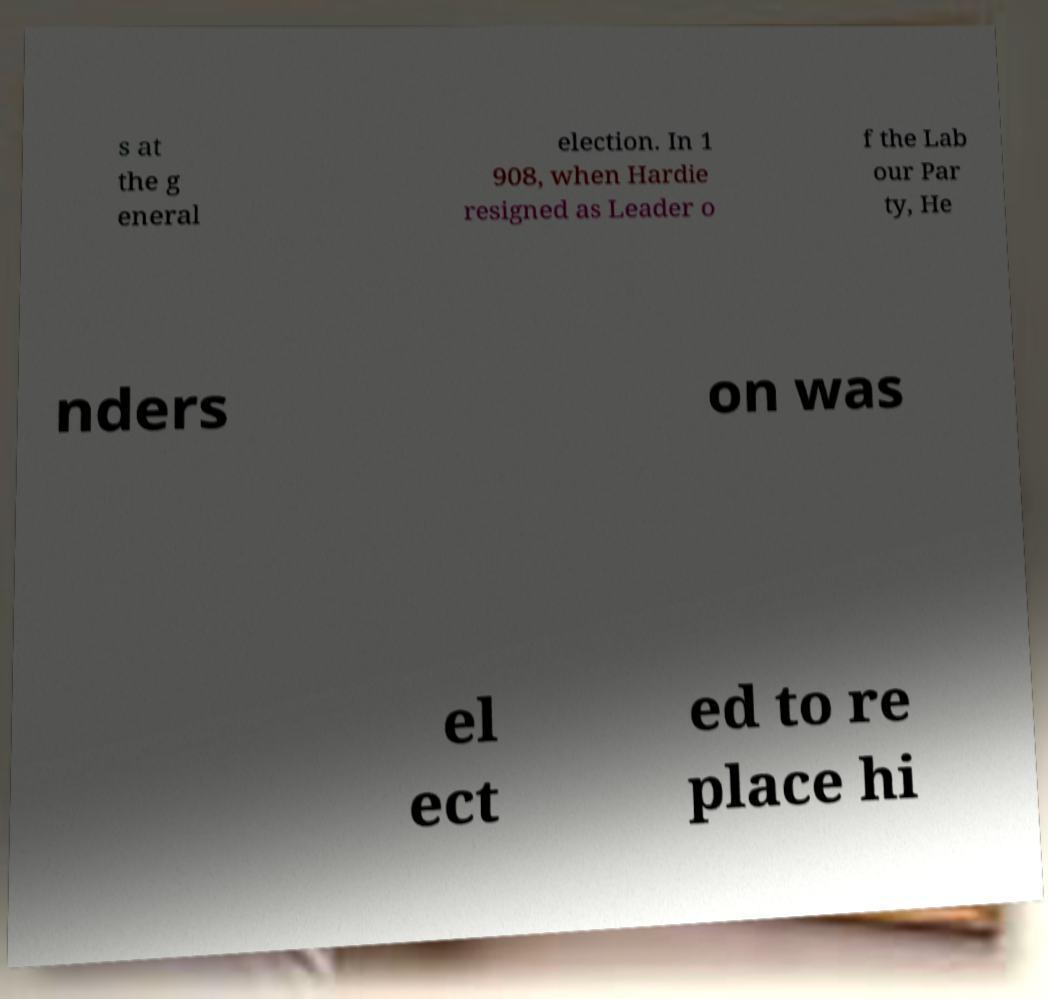For documentation purposes, I need the text within this image transcribed. Could you provide that? s at the g eneral election. In 1 908, when Hardie resigned as Leader o f the Lab our Par ty, He nders on was el ect ed to re place hi 